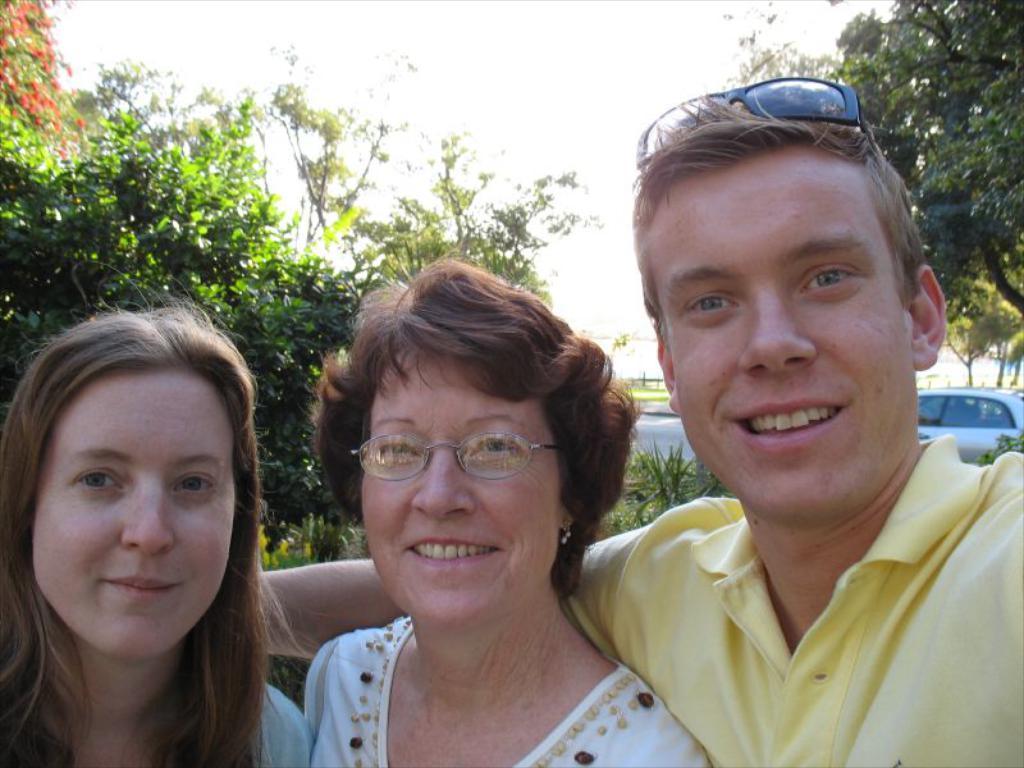Can you describe this image briefly? In this image there are persons in the front smiling. In the background there are trees and there is a car on the road and there's grass on the ground. 